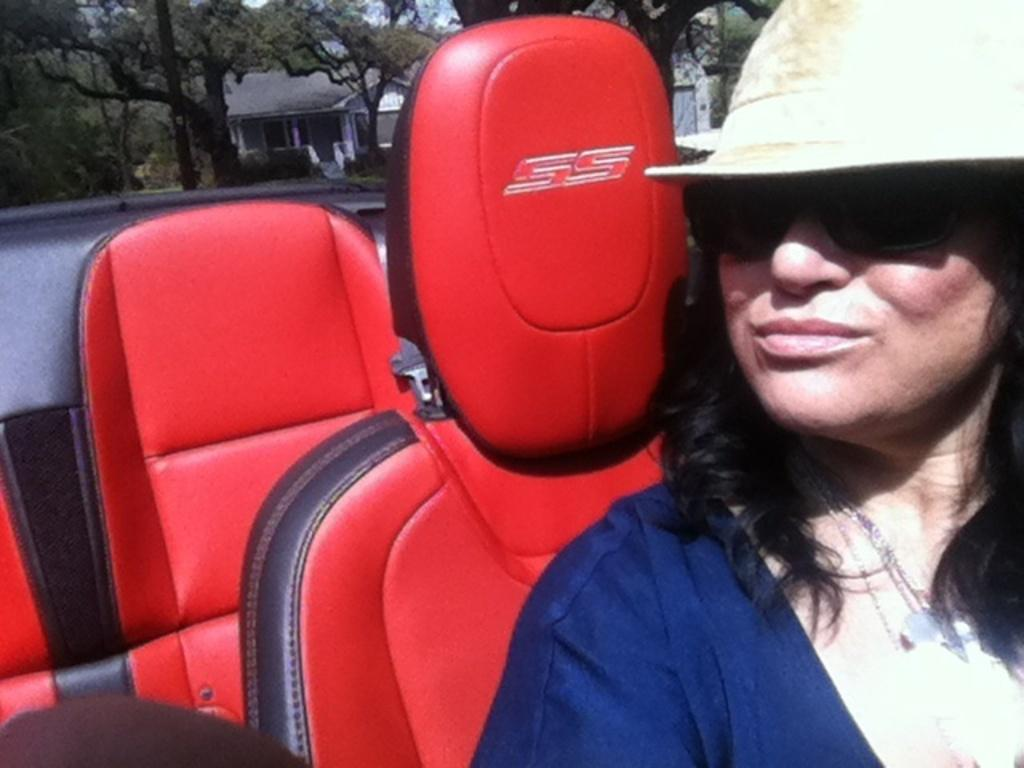What is the main subject of the image? The main subject of the image is a woman. Can you describe the woman's attire in the image? The woman is wearing clothes, a neck chain, goggles, and a hat in the image. What else can be seen in the image besides the woman? There is a vehicle, trees, and a building in the image. Can you describe the vehicle in the image? The vehicle has seats in the image. What is the purpose of the alley in the image? There is no alley present in the image. 